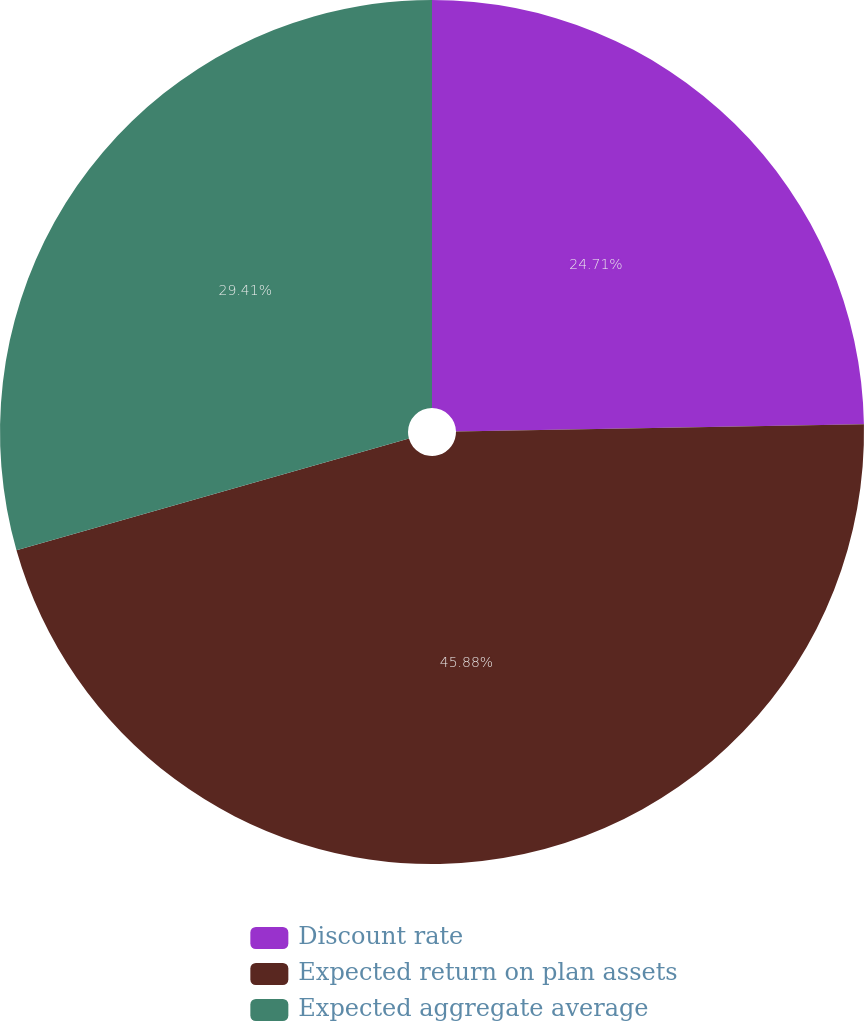<chart> <loc_0><loc_0><loc_500><loc_500><pie_chart><fcel>Discount rate<fcel>Expected return on plan assets<fcel>Expected aggregate average<nl><fcel>24.71%<fcel>45.88%<fcel>29.41%<nl></chart> 